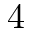<formula> <loc_0><loc_0><loc_500><loc_500>4</formula> 